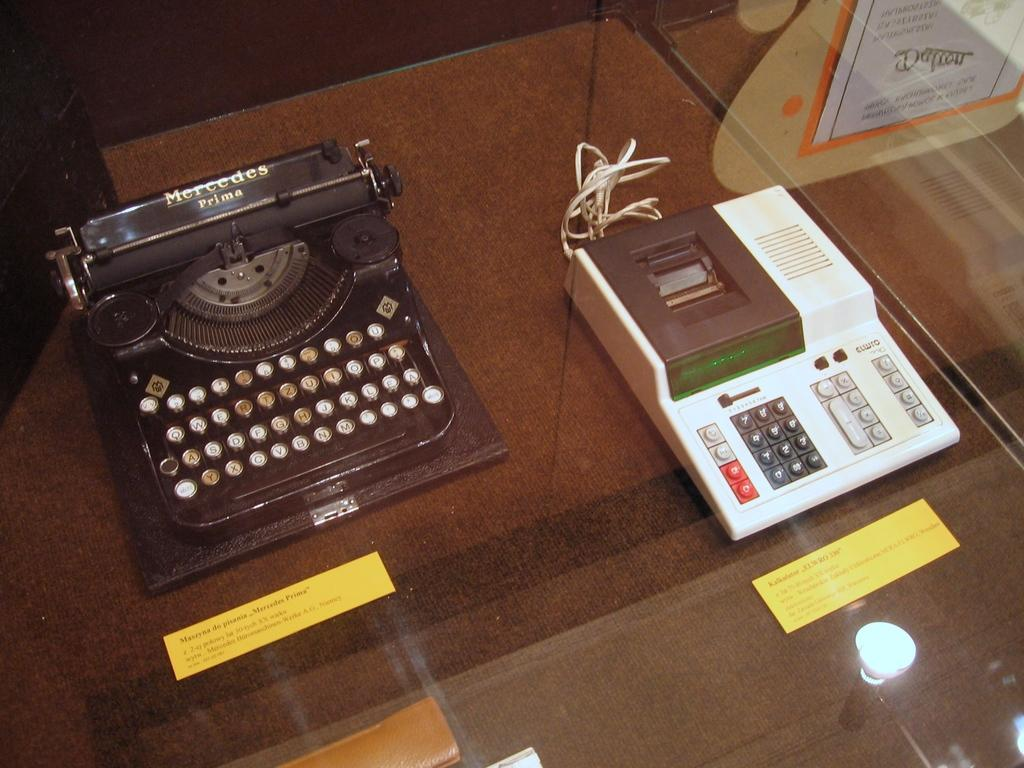<image>
Give a short and clear explanation of the subsequent image. A Mercedes Prime brand typewriter is displayed next to an old calculator. 